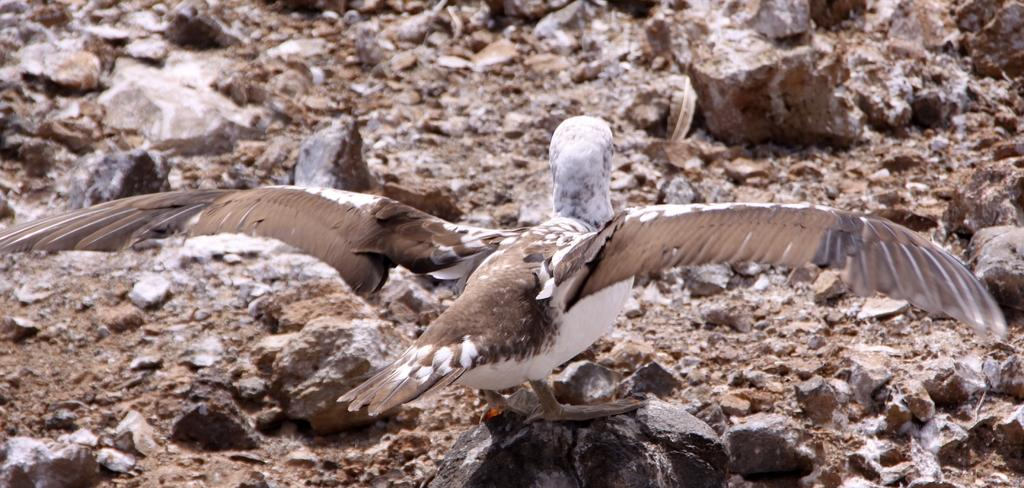What type of animal is in the image? There is a bird in the image. Where is the bird located? The bird is on a stone. What can be seen in the background of the image? There are stones and rocks in the background of the image. Can you tell if the image was taken during the day or night? The image was likely taken during the day, as there is no indication of darkness or artificial light. What type of flowers are in the crate next to the bird? There is no crate or flowers present in the image; it only features a bird on a stone and stones and rocks in the background. 